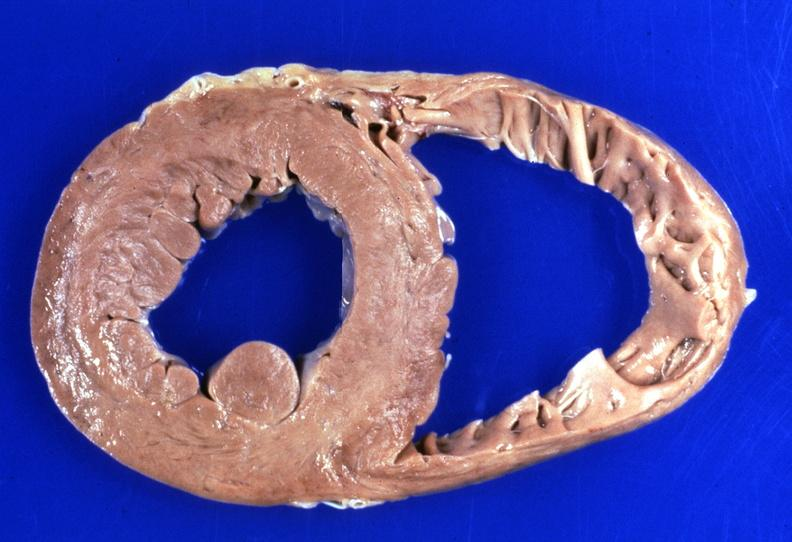what does this image show?
Answer the question using a single word or phrase. Heart 